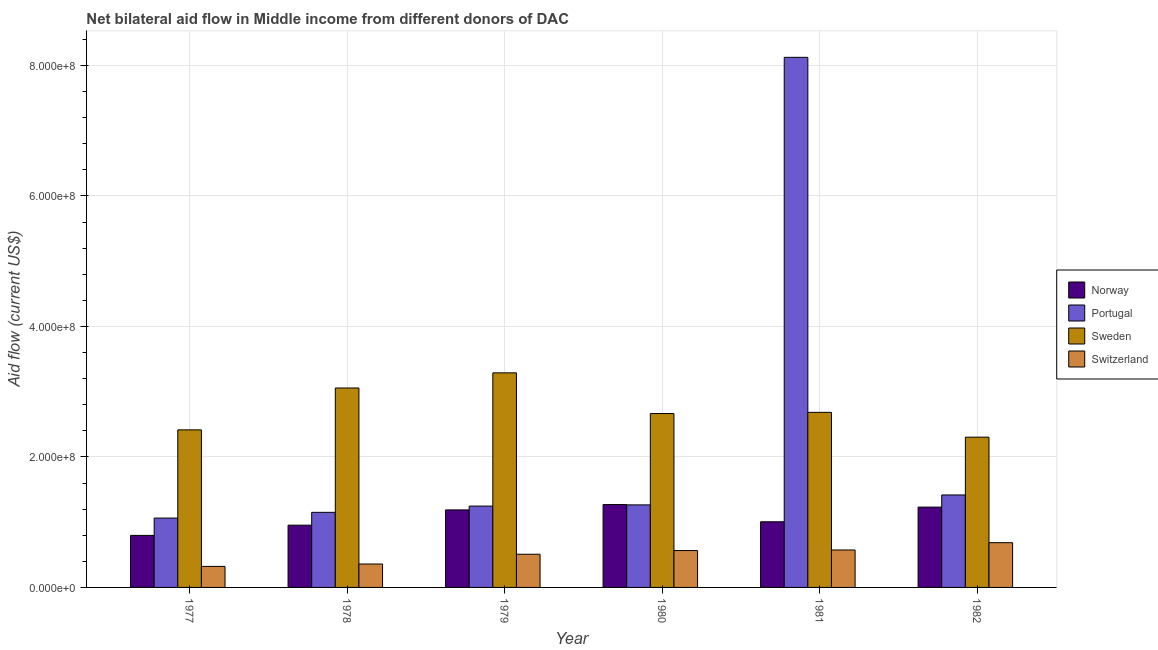How many bars are there on the 6th tick from the left?
Your response must be concise. 4. What is the label of the 4th group of bars from the left?
Your response must be concise. 1980. What is the amount of aid given by portugal in 1980?
Provide a short and direct response. 1.27e+08. Across all years, what is the maximum amount of aid given by norway?
Your response must be concise. 1.27e+08. Across all years, what is the minimum amount of aid given by sweden?
Provide a short and direct response. 2.30e+08. What is the total amount of aid given by sweden in the graph?
Your response must be concise. 1.64e+09. What is the difference between the amount of aid given by sweden in 1979 and that in 1981?
Your answer should be compact. 6.05e+07. What is the difference between the amount of aid given by norway in 1977 and the amount of aid given by switzerland in 1982?
Your answer should be very brief. -4.34e+07. What is the average amount of aid given by norway per year?
Give a very brief answer. 1.07e+08. In the year 1977, what is the difference between the amount of aid given by portugal and amount of aid given by norway?
Your answer should be compact. 0. In how many years, is the amount of aid given by sweden greater than 640000000 US$?
Give a very brief answer. 0. What is the ratio of the amount of aid given by norway in 1979 to that in 1982?
Your answer should be compact. 0.97. What is the difference between the highest and the second highest amount of aid given by switzerland?
Provide a succinct answer. 1.12e+07. What is the difference between the highest and the lowest amount of aid given by portugal?
Provide a short and direct response. 7.06e+08. In how many years, is the amount of aid given by norway greater than the average amount of aid given by norway taken over all years?
Provide a short and direct response. 3. What does the 1st bar from the left in 1979 represents?
Ensure brevity in your answer.  Norway. What does the 4th bar from the right in 1981 represents?
Make the answer very short. Norway. How many bars are there?
Offer a terse response. 24. How many years are there in the graph?
Offer a terse response. 6. What is the difference between two consecutive major ticks on the Y-axis?
Provide a short and direct response. 2.00e+08. Are the values on the major ticks of Y-axis written in scientific E-notation?
Make the answer very short. Yes. How many legend labels are there?
Provide a succinct answer. 4. How are the legend labels stacked?
Your answer should be very brief. Vertical. What is the title of the graph?
Your answer should be very brief. Net bilateral aid flow in Middle income from different donors of DAC. Does "Methodology assessment" appear as one of the legend labels in the graph?
Provide a succinct answer. No. What is the label or title of the X-axis?
Offer a terse response. Year. What is the label or title of the Y-axis?
Offer a very short reply. Aid flow (current US$). What is the Aid flow (current US$) in Norway in 1977?
Provide a short and direct response. 7.97e+07. What is the Aid flow (current US$) of Portugal in 1977?
Provide a succinct answer. 1.06e+08. What is the Aid flow (current US$) in Sweden in 1977?
Make the answer very short. 2.41e+08. What is the Aid flow (current US$) of Switzerland in 1977?
Your answer should be compact. 3.22e+07. What is the Aid flow (current US$) in Norway in 1978?
Give a very brief answer. 9.54e+07. What is the Aid flow (current US$) of Portugal in 1978?
Provide a short and direct response. 1.15e+08. What is the Aid flow (current US$) of Sweden in 1978?
Your answer should be very brief. 3.06e+08. What is the Aid flow (current US$) in Switzerland in 1978?
Your answer should be very brief. 3.59e+07. What is the Aid flow (current US$) of Norway in 1979?
Keep it short and to the point. 1.19e+08. What is the Aid flow (current US$) of Portugal in 1979?
Provide a succinct answer. 1.25e+08. What is the Aid flow (current US$) in Sweden in 1979?
Make the answer very short. 3.29e+08. What is the Aid flow (current US$) of Switzerland in 1979?
Offer a terse response. 5.09e+07. What is the Aid flow (current US$) in Norway in 1980?
Your answer should be very brief. 1.27e+08. What is the Aid flow (current US$) in Portugal in 1980?
Offer a very short reply. 1.27e+08. What is the Aid flow (current US$) in Sweden in 1980?
Make the answer very short. 2.67e+08. What is the Aid flow (current US$) in Switzerland in 1980?
Make the answer very short. 5.65e+07. What is the Aid flow (current US$) in Norway in 1981?
Your answer should be very brief. 1.01e+08. What is the Aid flow (current US$) in Portugal in 1981?
Offer a terse response. 8.12e+08. What is the Aid flow (current US$) in Sweden in 1981?
Make the answer very short. 2.68e+08. What is the Aid flow (current US$) in Switzerland in 1981?
Make the answer very short. 5.74e+07. What is the Aid flow (current US$) of Norway in 1982?
Make the answer very short. 1.23e+08. What is the Aid flow (current US$) of Portugal in 1982?
Keep it short and to the point. 1.42e+08. What is the Aid flow (current US$) in Sweden in 1982?
Your answer should be compact. 2.30e+08. What is the Aid flow (current US$) in Switzerland in 1982?
Provide a short and direct response. 6.86e+07. Across all years, what is the maximum Aid flow (current US$) of Norway?
Make the answer very short. 1.27e+08. Across all years, what is the maximum Aid flow (current US$) of Portugal?
Your response must be concise. 8.12e+08. Across all years, what is the maximum Aid flow (current US$) in Sweden?
Your response must be concise. 3.29e+08. Across all years, what is the maximum Aid flow (current US$) in Switzerland?
Give a very brief answer. 6.86e+07. Across all years, what is the minimum Aid flow (current US$) in Norway?
Your answer should be very brief. 7.97e+07. Across all years, what is the minimum Aid flow (current US$) of Portugal?
Provide a short and direct response. 1.06e+08. Across all years, what is the minimum Aid flow (current US$) of Sweden?
Offer a terse response. 2.30e+08. Across all years, what is the minimum Aid flow (current US$) in Switzerland?
Make the answer very short. 3.22e+07. What is the total Aid flow (current US$) in Norway in the graph?
Keep it short and to the point. 6.45e+08. What is the total Aid flow (current US$) of Portugal in the graph?
Provide a succinct answer. 1.43e+09. What is the total Aid flow (current US$) of Sweden in the graph?
Your answer should be very brief. 1.64e+09. What is the total Aid flow (current US$) of Switzerland in the graph?
Keep it short and to the point. 3.01e+08. What is the difference between the Aid flow (current US$) of Norway in 1977 and that in 1978?
Ensure brevity in your answer.  -1.57e+07. What is the difference between the Aid flow (current US$) in Portugal in 1977 and that in 1978?
Offer a very short reply. -8.78e+06. What is the difference between the Aid flow (current US$) of Sweden in 1977 and that in 1978?
Your answer should be compact. -6.42e+07. What is the difference between the Aid flow (current US$) of Switzerland in 1977 and that in 1978?
Provide a succinct answer. -3.61e+06. What is the difference between the Aid flow (current US$) in Norway in 1977 and that in 1979?
Your answer should be very brief. -3.91e+07. What is the difference between the Aid flow (current US$) of Portugal in 1977 and that in 1979?
Your response must be concise. -1.84e+07. What is the difference between the Aid flow (current US$) of Sweden in 1977 and that in 1979?
Make the answer very short. -8.74e+07. What is the difference between the Aid flow (current US$) of Switzerland in 1977 and that in 1979?
Make the answer very short. -1.86e+07. What is the difference between the Aid flow (current US$) in Norway in 1977 and that in 1980?
Your response must be concise. -4.73e+07. What is the difference between the Aid flow (current US$) of Portugal in 1977 and that in 1980?
Your answer should be very brief. -2.02e+07. What is the difference between the Aid flow (current US$) in Sweden in 1977 and that in 1980?
Ensure brevity in your answer.  -2.50e+07. What is the difference between the Aid flow (current US$) in Switzerland in 1977 and that in 1980?
Make the answer very short. -2.43e+07. What is the difference between the Aid flow (current US$) in Norway in 1977 and that in 1981?
Make the answer very short. -2.09e+07. What is the difference between the Aid flow (current US$) in Portugal in 1977 and that in 1981?
Provide a succinct answer. -7.06e+08. What is the difference between the Aid flow (current US$) in Sweden in 1977 and that in 1981?
Give a very brief answer. -2.68e+07. What is the difference between the Aid flow (current US$) in Switzerland in 1977 and that in 1981?
Your response must be concise. -2.51e+07. What is the difference between the Aid flow (current US$) in Norway in 1977 and that in 1982?
Your response must be concise. -4.34e+07. What is the difference between the Aid flow (current US$) of Portugal in 1977 and that in 1982?
Provide a short and direct response. -3.54e+07. What is the difference between the Aid flow (current US$) in Sweden in 1977 and that in 1982?
Your answer should be very brief. 1.12e+07. What is the difference between the Aid flow (current US$) in Switzerland in 1977 and that in 1982?
Your answer should be very brief. -3.63e+07. What is the difference between the Aid flow (current US$) of Norway in 1978 and that in 1979?
Give a very brief answer. -2.34e+07. What is the difference between the Aid flow (current US$) in Portugal in 1978 and that in 1979?
Provide a short and direct response. -9.59e+06. What is the difference between the Aid flow (current US$) of Sweden in 1978 and that in 1979?
Give a very brief answer. -2.32e+07. What is the difference between the Aid flow (current US$) of Switzerland in 1978 and that in 1979?
Offer a very short reply. -1.50e+07. What is the difference between the Aid flow (current US$) in Norway in 1978 and that in 1980?
Offer a terse response. -3.16e+07. What is the difference between the Aid flow (current US$) in Portugal in 1978 and that in 1980?
Keep it short and to the point. -1.14e+07. What is the difference between the Aid flow (current US$) of Sweden in 1978 and that in 1980?
Your answer should be very brief. 3.92e+07. What is the difference between the Aid flow (current US$) of Switzerland in 1978 and that in 1980?
Keep it short and to the point. -2.07e+07. What is the difference between the Aid flow (current US$) in Norway in 1978 and that in 1981?
Your response must be concise. -5.23e+06. What is the difference between the Aid flow (current US$) of Portugal in 1978 and that in 1981?
Make the answer very short. -6.97e+08. What is the difference between the Aid flow (current US$) in Sweden in 1978 and that in 1981?
Keep it short and to the point. 3.73e+07. What is the difference between the Aid flow (current US$) of Switzerland in 1978 and that in 1981?
Offer a very short reply. -2.15e+07. What is the difference between the Aid flow (current US$) of Norway in 1978 and that in 1982?
Ensure brevity in your answer.  -2.77e+07. What is the difference between the Aid flow (current US$) of Portugal in 1978 and that in 1982?
Your answer should be compact. -2.66e+07. What is the difference between the Aid flow (current US$) of Sweden in 1978 and that in 1982?
Offer a very short reply. 7.54e+07. What is the difference between the Aid flow (current US$) in Switzerland in 1978 and that in 1982?
Give a very brief answer. -3.27e+07. What is the difference between the Aid flow (current US$) in Norway in 1979 and that in 1980?
Ensure brevity in your answer.  -8.17e+06. What is the difference between the Aid flow (current US$) of Portugal in 1979 and that in 1980?
Your response must be concise. -1.84e+06. What is the difference between the Aid flow (current US$) of Sweden in 1979 and that in 1980?
Keep it short and to the point. 6.23e+07. What is the difference between the Aid flow (current US$) of Switzerland in 1979 and that in 1980?
Make the answer very short. -5.68e+06. What is the difference between the Aid flow (current US$) in Norway in 1979 and that in 1981?
Keep it short and to the point. 1.82e+07. What is the difference between the Aid flow (current US$) of Portugal in 1979 and that in 1981?
Your answer should be very brief. -6.88e+08. What is the difference between the Aid flow (current US$) in Sweden in 1979 and that in 1981?
Provide a succinct answer. 6.05e+07. What is the difference between the Aid flow (current US$) of Switzerland in 1979 and that in 1981?
Offer a terse response. -6.53e+06. What is the difference between the Aid flow (current US$) in Norway in 1979 and that in 1982?
Ensure brevity in your answer.  -4.28e+06. What is the difference between the Aid flow (current US$) in Portugal in 1979 and that in 1982?
Provide a short and direct response. -1.71e+07. What is the difference between the Aid flow (current US$) in Sweden in 1979 and that in 1982?
Make the answer very short. 9.86e+07. What is the difference between the Aid flow (current US$) of Switzerland in 1979 and that in 1982?
Provide a short and direct response. -1.77e+07. What is the difference between the Aid flow (current US$) in Norway in 1980 and that in 1981?
Provide a succinct answer. 2.64e+07. What is the difference between the Aid flow (current US$) in Portugal in 1980 and that in 1981?
Keep it short and to the point. -6.86e+08. What is the difference between the Aid flow (current US$) in Sweden in 1980 and that in 1981?
Offer a terse response. -1.81e+06. What is the difference between the Aid flow (current US$) in Switzerland in 1980 and that in 1981?
Provide a succinct answer. -8.50e+05. What is the difference between the Aid flow (current US$) in Norway in 1980 and that in 1982?
Offer a terse response. 3.89e+06. What is the difference between the Aid flow (current US$) of Portugal in 1980 and that in 1982?
Offer a terse response. -1.52e+07. What is the difference between the Aid flow (current US$) of Sweden in 1980 and that in 1982?
Your response must be concise. 3.62e+07. What is the difference between the Aid flow (current US$) in Switzerland in 1980 and that in 1982?
Your response must be concise. -1.20e+07. What is the difference between the Aid flow (current US$) of Norway in 1981 and that in 1982?
Your answer should be very brief. -2.25e+07. What is the difference between the Aid flow (current US$) of Portugal in 1981 and that in 1982?
Provide a succinct answer. 6.71e+08. What is the difference between the Aid flow (current US$) in Sweden in 1981 and that in 1982?
Your answer should be compact. 3.80e+07. What is the difference between the Aid flow (current US$) of Switzerland in 1981 and that in 1982?
Provide a short and direct response. -1.12e+07. What is the difference between the Aid flow (current US$) of Norway in 1977 and the Aid flow (current US$) of Portugal in 1978?
Keep it short and to the point. -3.54e+07. What is the difference between the Aid flow (current US$) of Norway in 1977 and the Aid flow (current US$) of Sweden in 1978?
Your response must be concise. -2.26e+08. What is the difference between the Aid flow (current US$) in Norway in 1977 and the Aid flow (current US$) in Switzerland in 1978?
Provide a succinct answer. 4.39e+07. What is the difference between the Aid flow (current US$) in Portugal in 1977 and the Aid flow (current US$) in Sweden in 1978?
Your answer should be very brief. -1.99e+08. What is the difference between the Aid flow (current US$) in Portugal in 1977 and the Aid flow (current US$) in Switzerland in 1978?
Make the answer very short. 7.04e+07. What is the difference between the Aid flow (current US$) of Sweden in 1977 and the Aid flow (current US$) of Switzerland in 1978?
Keep it short and to the point. 2.06e+08. What is the difference between the Aid flow (current US$) in Norway in 1977 and the Aid flow (current US$) in Portugal in 1979?
Provide a succinct answer. -4.49e+07. What is the difference between the Aid flow (current US$) of Norway in 1977 and the Aid flow (current US$) of Sweden in 1979?
Your answer should be compact. -2.49e+08. What is the difference between the Aid flow (current US$) of Norway in 1977 and the Aid flow (current US$) of Switzerland in 1979?
Your answer should be very brief. 2.89e+07. What is the difference between the Aid flow (current US$) of Portugal in 1977 and the Aid flow (current US$) of Sweden in 1979?
Your answer should be compact. -2.23e+08. What is the difference between the Aid flow (current US$) in Portugal in 1977 and the Aid flow (current US$) in Switzerland in 1979?
Offer a terse response. 5.54e+07. What is the difference between the Aid flow (current US$) in Sweden in 1977 and the Aid flow (current US$) in Switzerland in 1979?
Offer a very short reply. 1.91e+08. What is the difference between the Aid flow (current US$) of Norway in 1977 and the Aid flow (current US$) of Portugal in 1980?
Give a very brief answer. -4.68e+07. What is the difference between the Aid flow (current US$) in Norway in 1977 and the Aid flow (current US$) in Sweden in 1980?
Offer a terse response. -1.87e+08. What is the difference between the Aid flow (current US$) in Norway in 1977 and the Aid flow (current US$) in Switzerland in 1980?
Offer a terse response. 2.32e+07. What is the difference between the Aid flow (current US$) of Portugal in 1977 and the Aid flow (current US$) of Sweden in 1980?
Provide a short and direct response. -1.60e+08. What is the difference between the Aid flow (current US$) of Portugal in 1977 and the Aid flow (current US$) of Switzerland in 1980?
Ensure brevity in your answer.  4.98e+07. What is the difference between the Aid flow (current US$) of Sweden in 1977 and the Aid flow (current US$) of Switzerland in 1980?
Your response must be concise. 1.85e+08. What is the difference between the Aid flow (current US$) of Norway in 1977 and the Aid flow (current US$) of Portugal in 1981?
Keep it short and to the point. -7.33e+08. What is the difference between the Aid flow (current US$) in Norway in 1977 and the Aid flow (current US$) in Sweden in 1981?
Offer a terse response. -1.89e+08. What is the difference between the Aid flow (current US$) in Norway in 1977 and the Aid flow (current US$) in Switzerland in 1981?
Ensure brevity in your answer.  2.23e+07. What is the difference between the Aid flow (current US$) in Portugal in 1977 and the Aid flow (current US$) in Sweden in 1981?
Give a very brief answer. -1.62e+08. What is the difference between the Aid flow (current US$) in Portugal in 1977 and the Aid flow (current US$) in Switzerland in 1981?
Provide a succinct answer. 4.89e+07. What is the difference between the Aid flow (current US$) of Sweden in 1977 and the Aid flow (current US$) of Switzerland in 1981?
Your answer should be compact. 1.84e+08. What is the difference between the Aid flow (current US$) of Norway in 1977 and the Aid flow (current US$) of Portugal in 1982?
Offer a very short reply. -6.20e+07. What is the difference between the Aid flow (current US$) of Norway in 1977 and the Aid flow (current US$) of Sweden in 1982?
Your response must be concise. -1.51e+08. What is the difference between the Aid flow (current US$) in Norway in 1977 and the Aid flow (current US$) in Switzerland in 1982?
Give a very brief answer. 1.11e+07. What is the difference between the Aid flow (current US$) in Portugal in 1977 and the Aid flow (current US$) in Sweden in 1982?
Your answer should be very brief. -1.24e+08. What is the difference between the Aid flow (current US$) of Portugal in 1977 and the Aid flow (current US$) of Switzerland in 1982?
Make the answer very short. 3.77e+07. What is the difference between the Aid flow (current US$) in Sweden in 1977 and the Aid flow (current US$) in Switzerland in 1982?
Provide a short and direct response. 1.73e+08. What is the difference between the Aid flow (current US$) in Norway in 1978 and the Aid flow (current US$) in Portugal in 1979?
Make the answer very short. -2.93e+07. What is the difference between the Aid flow (current US$) in Norway in 1978 and the Aid flow (current US$) in Sweden in 1979?
Provide a succinct answer. -2.33e+08. What is the difference between the Aid flow (current US$) in Norway in 1978 and the Aid flow (current US$) in Switzerland in 1979?
Give a very brief answer. 4.45e+07. What is the difference between the Aid flow (current US$) of Portugal in 1978 and the Aid flow (current US$) of Sweden in 1979?
Provide a short and direct response. -2.14e+08. What is the difference between the Aid flow (current US$) of Portugal in 1978 and the Aid flow (current US$) of Switzerland in 1979?
Keep it short and to the point. 6.42e+07. What is the difference between the Aid flow (current US$) in Sweden in 1978 and the Aid flow (current US$) in Switzerland in 1979?
Make the answer very short. 2.55e+08. What is the difference between the Aid flow (current US$) in Norway in 1978 and the Aid flow (current US$) in Portugal in 1980?
Offer a very short reply. -3.11e+07. What is the difference between the Aid flow (current US$) in Norway in 1978 and the Aid flow (current US$) in Sweden in 1980?
Provide a short and direct response. -1.71e+08. What is the difference between the Aid flow (current US$) in Norway in 1978 and the Aid flow (current US$) in Switzerland in 1980?
Your answer should be compact. 3.89e+07. What is the difference between the Aid flow (current US$) in Portugal in 1978 and the Aid flow (current US$) in Sweden in 1980?
Make the answer very short. -1.51e+08. What is the difference between the Aid flow (current US$) of Portugal in 1978 and the Aid flow (current US$) of Switzerland in 1980?
Make the answer very short. 5.85e+07. What is the difference between the Aid flow (current US$) in Sweden in 1978 and the Aid flow (current US$) in Switzerland in 1980?
Your answer should be very brief. 2.49e+08. What is the difference between the Aid flow (current US$) in Norway in 1978 and the Aid flow (current US$) in Portugal in 1981?
Offer a terse response. -7.17e+08. What is the difference between the Aid flow (current US$) in Norway in 1978 and the Aid flow (current US$) in Sweden in 1981?
Offer a terse response. -1.73e+08. What is the difference between the Aid flow (current US$) of Norway in 1978 and the Aid flow (current US$) of Switzerland in 1981?
Offer a very short reply. 3.80e+07. What is the difference between the Aid flow (current US$) in Portugal in 1978 and the Aid flow (current US$) in Sweden in 1981?
Keep it short and to the point. -1.53e+08. What is the difference between the Aid flow (current US$) of Portugal in 1978 and the Aid flow (current US$) of Switzerland in 1981?
Offer a very short reply. 5.77e+07. What is the difference between the Aid flow (current US$) in Sweden in 1978 and the Aid flow (current US$) in Switzerland in 1981?
Ensure brevity in your answer.  2.48e+08. What is the difference between the Aid flow (current US$) of Norway in 1978 and the Aid flow (current US$) of Portugal in 1982?
Make the answer very short. -4.63e+07. What is the difference between the Aid flow (current US$) of Norway in 1978 and the Aid flow (current US$) of Sweden in 1982?
Give a very brief answer. -1.35e+08. What is the difference between the Aid flow (current US$) in Norway in 1978 and the Aid flow (current US$) in Switzerland in 1982?
Give a very brief answer. 2.68e+07. What is the difference between the Aid flow (current US$) of Portugal in 1978 and the Aid flow (current US$) of Sweden in 1982?
Your answer should be very brief. -1.15e+08. What is the difference between the Aid flow (current US$) of Portugal in 1978 and the Aid flow (current US$) of Switzerland in 1982?
Keep it short and to the point. 4.65e+07. What is the difference between the Aid flow (current US$) of Sweden in 1978 and the Aid flow (current US$) of Switzerland in 1982?
Provide a short and direct response. 2.37e+08. What is the difference between the Aid flow (current US$) in Norway in 1979 and the Aid flow (current US$) in Portugal in 1980?
Give a very brief answer. -7.69e+06. What is the difference between the Aid flow (current US$) of Norway in 1979 and the Aid flow (current US$) of Sweden in 1980?
Make the answer very short. -1.48e+08. What is the difference between the Aid flow (current US$) of Norway in 1979 and the Aid flow (current US$) of Switzerland in 1980?
Give a very brief answer. 6.23e+07. What is the difference between the Aid flow (current US$) of Portugal in 1979 and the Aid flow (current US$) of Sweden in 1980?
Keep it short and to the point. -1.42e+08. What is the difference between the Aid flow (current US$) in Portugal in 1979 and the Aid flow (current US$) in Switzerland in 1980?
Your answer should be compact. 6.81e+07. What is the difference between the Aid flow (current US$) in Sweden in 1979 and the Aid flow (current US$) in Switzerland in 1980?
Your answer should be compact. 2.72e+08. What is the difference between the Aid flow (current US$) in Norway in 1979 and the Aid flow (current US$) in Portugal in 1981?
Your answer should be very brief. -6.94e+08. What is the difference between the Aid flow (current US$) of Norway in 1979 and the Aid flow (current US$) of Sweden in 1981?
Your answer should be very brief. -1.50e+08. What is the difference between the Aid flow (current US$) in Norway in 1979 and the Aid flow (current US$) in Switzerland in 1981?
Keep it short and to the point. 6.14e+07. What is the difference between the Aid flow (current US$) of Portugal in 1979 and the Aid flow (current US$) of Sweden in 1981?
Provide a short and direct response. -1.44e+08. What is the difference between the Aid flow (current US$) in Portugal in 1979 and the Aid flow (current US$) in Switzerland in 1981?
Offer a very short reply. 6.73e+07. What is the difference between the Aid flow (current US$) of Sweden in 1979 and the Aid flow (current US$) of Switzerland in 1981?
Provide a short and direct response. 2.71e+08. What is the difference between the Aid flow (current US$) of Norway in 1979 and the Aid flow (current US$) of Portugal in 1982?
Offer a very short reply. -2.29e+07. What is the difference between the Aid flow (current US$) in Norway in 1979 and the Aid flow (current US$) in Sweden in 1982?
Your response must be concise. -1.11e+08. What is the difference between the Aid flow (current US$) in Norway in 1979 and the Aid flow (current US$) in Switzerland in 1982?
Make the answer very short. 5.02e+07. What is the difference between the Aid flow (current US$) in Portugal in 1979 and the Aid flow (current US$) in Sweden in 1982?
Give a very brief answer. -1.06e+08. What is the difference between the Aid flow (current US$) of Portugal in 1979 and the Aid flow (current US$) of Switzerland in 1982?
Provide a short and direct response. 5.61e+07. What is the difference between the Aid flow (current US$) of Sweden in 1979 and the Aid flow (current US$) of Switzerland in 1982?
Your answer should be compact. 2.60e+08. What is the difference between the Aid flow (current US$) of Norway in 1980 and the Aid flow (current US$) of Portugal in 1981?
Your response must be concise. -6.85e+08. What is the difference between the Aid flow (current US$) in Norway in 1980 and the Aid flow (current US$) in Sweden in 1981?
Keep it short and to the point. -1.41e+08. What is the difference between the Aid flow (current US$) of Norway in 1980 and the Aid flow (current US$) of Switzerland in 1981?
Make the answer very short. 6.96e+07. What is the difference between the Aid flow (current US$) of Portugal in 1980 and the Aid flow (current US$) of Sweden in 1981?
Your response must be concise. -1.42e+08. What is the difference between the Aid flow (current US$) in Portugal in 1980 and the Aid flow (current US$) in Switzerland in 1981?
Offer a very short reply. 6.91e+07. What is the difference between the Aid flow (current US$) of Sweden in 1980 and the Aid flow (current US$) of Switzerland in 1981?
Ensure brevity in your answer.  2.09e+08. What is the difference between the Aid flow (current US$) of Norway in 1980 and the Aid flow (current US$) of Portugal in 1982?
Provide a succinct answer. -1.47e+07. What is the difference between the Aid flow (current US$) of Norway in 1980 and the Aid flow (current US$) of Sweden in 1982?
Offer a terse response. -1.03e+08. What is the difference between the Aid flow (current US$) of Norway in 1980 and the Aid flow (current US$) of Switzerland in 1982?
Your response must be concise. 5.84e+07. What is the difference between the Aid flow (current US$) of Portugal in 1980 and the Aid flow (current US$) of Sweden in 1982?
Your answer should be compact. -1.04e+08. What is the difference between the Aid flow (current US$) in Portugal in 1980 and the Aid flow (current US$) in Switzerland in 1982?
Keep it short and to the point. 5.79e+07. What is the difference between the Aid flow (current US$) of Sweden in 1980 and the Aid flow (current US$) of Switzerland in 1982?
Your response must be concise. 1.98e+08. What is the difference between the Aid flow (current US$) of Norway in 1981 and the Aid flow (current US$) of Portugal in 1982?
Your answer should be very brief. -4.11e+07. What is the difference between the Aid flow (current US$) of Norway in 1981 and the Aid flow (current US$) of Sweden in 1982?
Ensure brevity in your answer.  -1.30e+08. What is the difference between the Aid flow (current US$) of Norway in 1981 and the Aid flow (current US$) of Switzerland in 1982?
Provide a short and direct response. 3.20e+07. What is the difference between the Aid flow (current US$) in Portugal in 1981 and the Aid flow (current US$) in Sweden in 1982?
Offer a very short reply. 5.82e+08. What is the difference between the Aid flow (current US$) in Portugal in 1981 and the Aid flow (current US$) in Switzerland in 1982?
Keep it short and to the point. 7.44e+08. What is the difference between the Aid flow (current US$) of Sweden in 1981 and the Aid flow (current US$) of Switzerland in 1982?
Your response must be concise. 2.00e+08. What is the average Aid flow (current US$) in Norway per year?
Offer a very short reply. 1.07e+08. What is the average Aid flow (current US$) of Portugal per year?
Your response must be concise. 2.38e+08. What is the average Aid flow (current US$) in Sweden per year?
Offer a terse response. 2.74e+08. What is the average Aid flow (current US$) of Switzerland per year?
Ensure brevity in your answer.  5.02e+07. In the year 1977, what is the difference between the Aid flow (current US$) in Norway and Aid flow (current US$) in Portugal?
Your response must be concise. -2.66e+07. In the year 1977, what is the difference between the Aid flow (current US$) of Norway and Aid flow (current US$) of Sweden?
Offer a very short reply. -1.62e+08. In the year 1977, what is the difference between the Aid flow (current US$) of Norway and Aid flow (current US$) of Switzerland?
Keep it short and to the point. 4.75e+07. In the year 1977, what is the difference between the Aid flow (current US$) of Portugal and Aid flow (current US$) of Sweden?
Ensure brevity in your answer.  -1.35e+08. In the year 1977, what is the difference between the Aid flow (current US$) in Portugal and Aid flow (current US$) in Switzerland?
Ensure brevity in your answer.  7.40e+07. In the year 1977, what is the difference between the Aid flow (current US$) of Sweden and Aid flow (current US$) of Switzerland?
Offer a terse response. 2.09e+08. In the year 1978, what is the difference between the Aid flow (current US$) of Norway and Aid flow (current US$) of Portugal?
Offer a very short reply. -1.97e+07. In the year 1978, what is the difference between the Aid flow (current US$) of Norway and Aid flow (current US$) of Sweden?
Provide a succinct answer. -2.10e+08. In the year 1978, what is the difference between the Aid flow (current US$) of Norway and Aid flow (current US$) of Switzerland?
Provide a succinct answer. 5.95e+07. In the year 1978, what is the difference between the Aid flow (current US$) of Portugal and Aid flow (current US$) of Sweden?
Make the answer very short. -1.91e+08. In the year 1978, what is the difference between the Aid flow (current US$) of Portugal and Aid flow (current US$) of Switzerland?
Provide a short and direct response. 7.92e+07. In the year 1978, what is the difference between the Aid flow (current US$) of Sweden and Aid flow (current US$) of Switzerland?
Offer a terse response. 2.70e+08. In the year 1979, what is the difference between the Aid flow (current US$) in Norway and Aid flow (current US$) in Portugal?
Ensure brevity in your answer.  -5.85e+06. In the year 1979, what is the difference between the Aid flow (current US$) of Norway and Aid flow (current US$) of Sweden?
Offer a very short reply. -2.10e+08. In the year 1979, what is the difference between the Aid flow (current US$) in Norway and Aid flow (current US$) in Switzerland?
Your answer should be very brief. 6.80e+07. In the year 1979, what is the difference between the Aid flow (current US$) of Portugal and Aid flow (current US$) of Sweden?
Keep it short and to the point. -2.04e+08. In the year 1979, what is the difference between the Aid flow (current US$) in Portugal and Aid flow (current US$) in Switzerland?
Make the answer very short. 7.38e+07. In the year 1979, what is the difference between the Aid flow (current US$) of Sweden and Aid flow (current US$) of Switzerland?
Provide a succinct answer. 2.78e+08. In the year 1980, what is the difference between the Aid flow (current US$) of Norway and Aid flow (current US$) of Sweden?
Keep it short and to the point. -1.40e+08. In the year 1980, what is the difference between the Aid flow (current US$) of Norway and Aid flow (current US$) of Switzerland?
Make the answer very short. 7.04e+07. In the year 1980, what is the difference between the Aid flow (current US$) of Portugal and Aid flow (current US$) of Sweden?
Offer a terse response. -1.40e+08. In the year 1980, what is the difference between the Aid flow (current US$) in Portugal and Aid flow (current US$) in Switzerland?
Make the answer very short. 7.00e+07. In the year 1980, what is the difference between the Aid flow (current US$) of Sweden and Aid flow (current US$) of Switzerland?
Ensure brevity in your answer.  2.10e+08. In the year 1981, what is the difference between the Aid flow (current US$) of Norway and Aid flow (current US$) of Portugal?
Provide a succinct answer. -7.12e+08. In the year 1981, what is the difference between the Aid flow (current US$) of Norway and Aid flow (current US$) of Sweden?
Your response must be concise. -1.68e+08. In the year 1981, what is the difference between the Aid flow (current US$) in Norway and Aid flow (current US$) in Switzerland?
Offer a very short reply. 4.32e+07. In the year 1981, what is the difference between the Aid flow (current US$) of Portugal and Aid flow (current US$) of Sweden?
Your response must be concise. 5.44e+08. In the year 1981, what is the difference between the Aid flow (current US$) of Portugal and Aid flow (current US$) of Switzerland?
Make the answer very short. 7.55e+08. In the year 1981, what is the difference between the Aid flow (current US$) of Sweden and Aid flow (current US$) of Switzerland?
Offer a terse response. 2.11e+08. In the year 1982, what is the difference between the Aid flow (current US$) in Norway and Aid flow (current US$) in Portugal?
Your answer should be compact. -1.86e+07. In the year 1982, what is the difference between the Aid flow (current US$) of Norway and Aid flow (current US$) of Sweden?
Make the answer very short. -1.07e+08. In the year 1982, what is the difference between the Aid flow (current US$) in Norway and Aid flow (current US$) in Switzerland?
Your answer should be compact. 5.45e+07. In the year 1982, what is the difference between the Aid flow (current US$) of Portugal and Aid flow (current US$) of Sweden?
Ensure brevity in your answer.  -8.86e+07. In the year 1982, what is the difference between the Aid flow (current US$) in Portugal and Aid flow (current US$) in Switzerland?
Make the answer very short. 7.31e+07. In the year 1982, what is the difference between the Aid flow (current US$) of Sweden and Aid flow (current US$) of Switzerland?
Make the answer very short. 1.62e+08. What is the ratio of the Aid flow (current US$) of Norway in 1977 to that in 1978?
Your response must be concise. 0.84. What is the ratio of the Aid flow (current US$) of Portugal in 1977 to that in 1978?
Keep it short and to the point. 0.92. What is the ratio of the Aid flow (current US$) of Sweden in 1977 to that in 1978?
Offer a very short reply. 0.79. What is the ratio of the Aid flow (current US$) of Switzerland in 1977 to that in 1978?
Your answer should be very brief. 0.9. What is the ratio of the Aid flow (current US$) of Norway in 1977 to that in 1979?
Your answer should be compact. 0.67. What is the ratio of the Aid flow (current US$) in Portugal in 1977 to that in 1979?
Provide a succinct answer. 0.85. What is the ratio of the Aid flow (current US$) in Sweden in 1977 to that in 1979?
Keep it short and to the point. 0.73. What is the ratio of the Aid flow (current US$) of Switzerland in 1977 to that in 1979?
Your answer should be compact. 0.63. What is the ratio of the Aid flow (current US$) in Norway in 1977 to that in 1980?
Your answer should be compact. 0.63. What is the ratio of the Aid flow (current US$) in Portugal in 1977 to that in 1980?
Make the answer very short. 0.84. What is the ratio of the Aid flow (current US$) of Sweden in 1977 to that in 1980?
Keep it short and to the point. 0.91. What is the ratio of the Aid flow (current US$) of Switzerland in 1977 to that in 1980?
Provide a succinct answer. 0.57. What is the ratio of the Aid flow (current US$) of Norway in 1977 to that in 1981?
Your answer should be compact. 0.79. What is the ratio of the Aid flow (current US$) of Portugal in 1977 to that in 1981?
Offer a terse response. 0.13. What is the ratio of the Aid flow (current US$) in Switzerland in 1977 to that in 1981?
Offer a terse response. 0.56. What is the ratio of the Aid flow (current US$) in Norway in 1977 to that in 1982?
Offer a terse response. 0.65. What is the ratio of the Aid flow (current US$) in Sweden in 1977 to that in 1982?
Make the answer very short. 1.05. What is the ratio of the Aid flow (current US$) of Switzerland in 1977 to that in 1982?
Your answer should be compact. 0.47. What is the ratio of the Aid flow (current US$) in Norway in 1978 to that in 1979?
Your answer should be compact. 0.8. What is the ratio of the Aid flow (current US$) of Portugal in 1978 to that in 1979?
Give a very brief answer. 0.92. What is the ratio of the Aid flow (current US$) of Sweden in 1978 to that in 1979?
Offer a very short reply. 0.93. What is the ratio of the Aid flow (current US$) in Switzerland in 1978 to that in 1979?
Provide a short and direct response. 0.71. What is the ratio of the Aid flow (current US$) in Norway in 1978 to that in 1980?
Keep it short and to the point. 0.75. What is the ratio of the Aid flow (current US$) of Portugal in 1978 to that in 1980?
Give a very brief answer. 0.91. What is the ratio of the Aid flow (current US$) of Sweden in 1978 to that in 1980?
Offer a terse response. 1.15. What is the ratio of the Aid flow (current US$) in Switzerland in 1978 to that in 1980?
Provide a short and direct response. 0.63. What is the ratio of the Aid flow (current US$) of Norway in 1978 to that in 1981?
Your response must be concise. 0.95. What is the ratio of the Aid flow (current US$) in Portugal in 1978 to that in 1981?
Your response must be concise. 0.14. What is the ratio of the Aid flow (current US$) of Sweden in 1978 to that in 1981?
Your response must be concise. 1.14. What is the ratio of the Aid flow (current US$) of Switzerland in 1978 to that in 1981?
Your answer should be compact. 0.62. What is the ratio of the Aid flow (current US$) in Norway in 1978 to that in 1982?
Your answer should be very brief. 0.78. What is the ratio of the Aid flow (current US$) of Portugal in 1978 to that in 1982?
Your answer should be very brief. 0.81. What is the ratio of the Aid flow (current US$) in Sweden in 1978 to that in 1982?
Your answer should be very brief. 1.33. What is the ratio of the Aid flow (current US$) in Switzerland in 1978 to that in 1982?
Ensure brevity in your answer.  0.52. What is the ratio of the Aid flow (current US$) in Norway in 1979 to that in 1980?
Your response must be concise. 0.94. What is the ratio of the Aid flow (current US$) of Portugal in 1979 to that in 1980?
Your answer should be very brief. 0.99. What is the ratio of the Aid flow (current US$) in Sweden in 1979 to that in 1980?
Ensure brevity in your answer.  1.23. What is the ratio of the Aid flow (current US$) in Switzerland in 1979 to that in 1980?
Your answer should be very brief. 0.9. What is the ratio of the Aid flow (current US$) of Norway in 1979 to that in 1981?
Your answer should be very brief. 1.18. What is the ratio of the Aid flow (current US$) of Portugal in 1979 to that in 1981?
Your response must be concise. 0.15. What is the ratio of the Aid flow (current US$) of Sweden in 1979 to that in 1981?
Your answer should be compact. 1.23. What is the ratio of the Aid flow (current US$) of Switzerland in 1979 to that in 1981?
Keep it short and to the point. 0.89. What is the ratio of the Aid flow (current US$) in Norway in 1979 to that in 1982?
Make the answer very short. 0.97. What is the ratio of the Aid flow (current US$) in Portugal in 1979 to that in 1982?
Your response must be concise. 0.88. What is the ratio of the Aid flow (current US$) in Sweden in 1979 to that in 1982?
Your response must be concise. 1.43. What is the ratio of the Aid flow (current US$) of Switzerland in 1979 to that in 1982?
Offer a very short reply. 0.74. What is the ratio of the Aid flow (current US$) in Norway in 1980 to that in 1981?
Your answer should be very brief. 1.26. What is the ratio of the Aid flow (current US$) in Portugal in 1980 to that in 1981?
Offer a very short reply. 0.16. What is the ratio of the Aid flow (current US$) in Sweden in 1980 to that in 1981?
Your response must be concise. 0.99. What is the ratio of the Aid flow (current US$) in Switzerland in 1980 to that in 1981?
Offer a terse response. 0.99. What is the ratio of the Aid flow (current US$) in Norway in 1980 to that in 1982?
Keep it short and to the point. 1.03. What is the ratio of the Aid flow (current US$) of Portugal in 1980 to that in 1982?
Offer a very short reply. 0.89. What is the ratio of the Aid flow (current US$) in Sweden in 1980 to that in 1982?
Your response must be concise. 1.16. What is the ratio of the Aid flow (current US$) in Switzerland in 1980 to that in 1982?
Ensure brevity in your answer.  0.82. What is the ratio of the Aid flow (current US$) in Norway in 1981 to that in 1982?
Provide a succinct answer. 0.82. What is the ratio of the Aid flow (current US$) of Portugal in 1981 to that in 1982?
Offer a very short reply. 5.73. What is the ratio of the Aid flow (current US$) of Sweden in 1981 to that in 1982?
Your answer should be compact. 1.17. What is the ratio of the Aid flow (current US$) in Switzerland in 1981 to that in 1982?
Provide a succinct answer. 0.84. What is the difference between the highest and the second highest Aid flow (current US$) of Norway?
Make the answer very short. 3.89e+06. What is the difference between the highest and the second highest Aid flow (current US$) in Portugal?
Give a very brief answer. 6.71e+08. What is the difference between the highest and the second highest Aid flow (current US$) of Sweden?
Make the answer very short. 2.32e+07. What is the difference between the highest and the second highest Aid flow (current US$) in Switzerland?
Provide a succinct answer. 1.12e+07. What is the difference between the highest and the lowest Aid flow (current US$) in Norway?
Offer a very short reply. 4.73e+07. What is the difference between the highest and the lowest Aid flow (current US$) of Portugal?
Your answer should be very brief. 7.06e+08. What is the difference between the highest and the lowest Aid flow (current US$) of Sweden?
Give a very brief answer. 9.86e+07. What is the difference between the highest and the lowest Aid flow (current US$) in Switzerland?
Offer a terse response. 3.63e+07. 